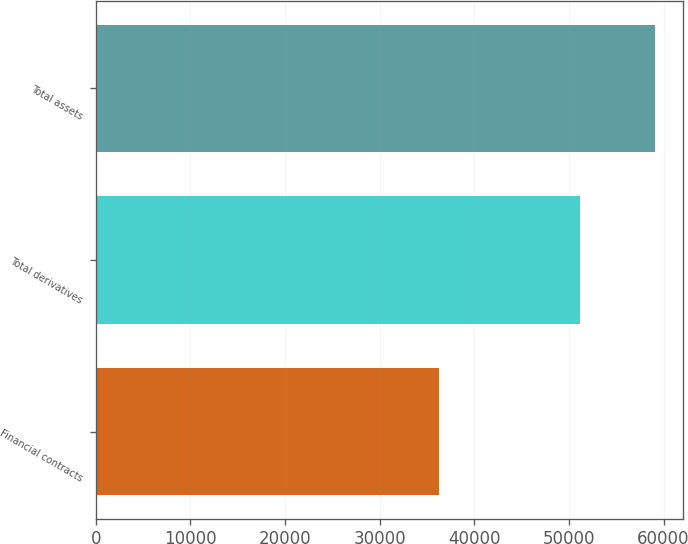<chart> <loc_0><loc_0><loc_500><loc_500><bar_chart><fcel>Financial contracts<fcel>Total derivatives<fcel>Total assets<nl><fcel>36242<fcel>51129<fcel>59134<nl></chart> 